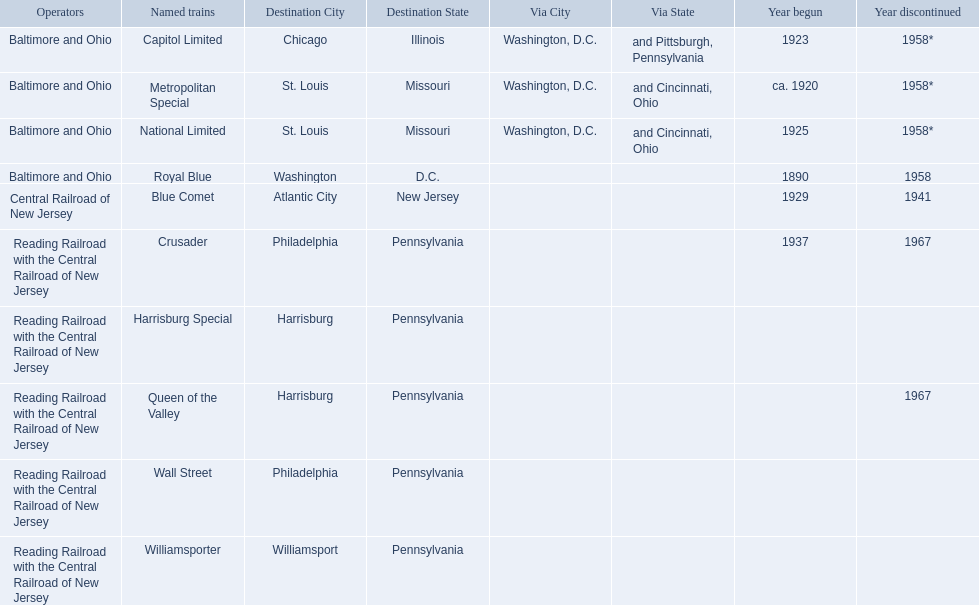Which operators are the reading railroad with the central railroad of new jersey? Reading Railroad with the Central Railroad of New Jersey, Reading Railroad with the Central Railroad of New Jersey, Reading Railroad with the Central Railroad of New Jersey, Reading Railroad with the Central Railroad of New Jersey, Reading Railroad with the Central Railroad of New Jersey. Which destinations are philadelphia, pennsylvania? Philadelphia, Pennsylvania, Philadelphia, Pennsylvania. What on began in 1937? 1937. What is the named train? Crusader. 